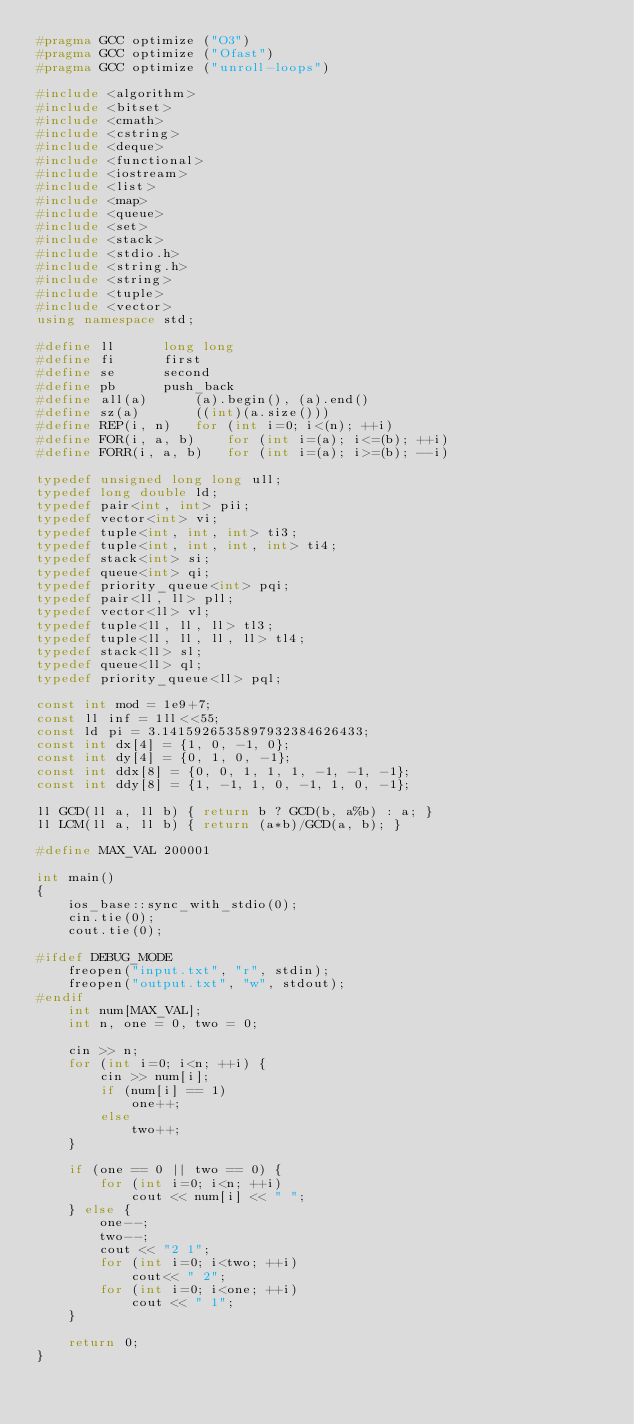<code> <loc_0><loc_0><loc_500><loc_500><_C++_>#pragma GCC optimize ("O3")
#pragma GCC optimize ("Ofast")
#pragma GCC optimize ("unroll-loops")

#include <algorithm>
#include <bitset>
#include <cmath>
#include <cstring>
#include <deque>
#include <functional>
#include <iostream>
#include <list>
#include <map>
#include <queue>
#include <set>
#include <stack>
#include <stdio.h>
#include <string.h>
#include <string>
#include <tuple>
#include <vector>
using namespace std;

#define ll		long long
#define fi		first
#define se		second
#define pb		push_back
#define all(a)		(a).begin(), (a).end()
#define sz(a)		((int)(a.size()))
#define REP(i, n)	for (int i=0; i<(n); ++i)
#define FOR(i, a, b)	for (int i=(a); i<=(b); ++i)
#define FORR(i, a, b)	for (int i=(a); i>=(b); --i)

typedef unsigned long long ull;
typedef long double ld;
typedef pair<int, int> pii;
typedef vector<int> vi;
typedef tuple<int, int, int> ti3;
typedef tuple<int, int, int, int> ti4;
typedef stack<int> si;
typedef queue<int> qi;
typedef priority_queue<int> pqi;
typedef pair<ll, ll> pll;
typedef vector<ll> vl;
typedef tuple<ll, ll, ll> tl3;
typedef tuple<ll, ll, ll, ll> tl4;
typedef stack<ll> sl;
typedef queue<ll> ql;
typedef priority_queue<ll> pql;

const int mod = 1e9+7;
const ll inf = 1ll<<55;
const ld pi = 3.1415926535897932384626433;
const int dx[4] = {1, 0, -1, 0};
const int dy[4] = {0, 1, 0, -1};
const int ddx[8] = {0, 0, 1, 1, 1, -1, -1, -1};
const int ddy[8] = {1, -1, 1, 0, -1, 1, 0, -1};

ll GCD(ll a, ll b) { return b ? GCD(b, a%b) : a; }
ll LCM(ll a, ll b) { return (a*b)/GCD(a, b); }

#define MAX_VAL 200001

int main()
{
	ios_base::sync_with_stdio(0);
	cin.tie(0);
	cout.tie(0);

#ifdef DEBUG_MODE
	freopen("input.txt", "r", stdin);
	freopen("output.txt", "w", stdout);
#endif
	int num[MAX_VAL];
	int n, one = 0, two = 0;

	cin >> n;
	for (int i=0; i<n; ++i) {
		cin >> num[i];
		if (num[i] == 1)
			one++;
		else
			two++;
	}

	if (one == 0 || two == 0) {
		for (int i=0; i<n; ++i)
			cout << num[i] << " ";
	} else {
		one--;
		two--;
		cout << "2 1";
		for (int i=0; i<two; ++i)
			cout<< " 2";
		for (int i=0; i<one; ++i)
			cout << " 1";
	}

	return 0;
}
</code> 